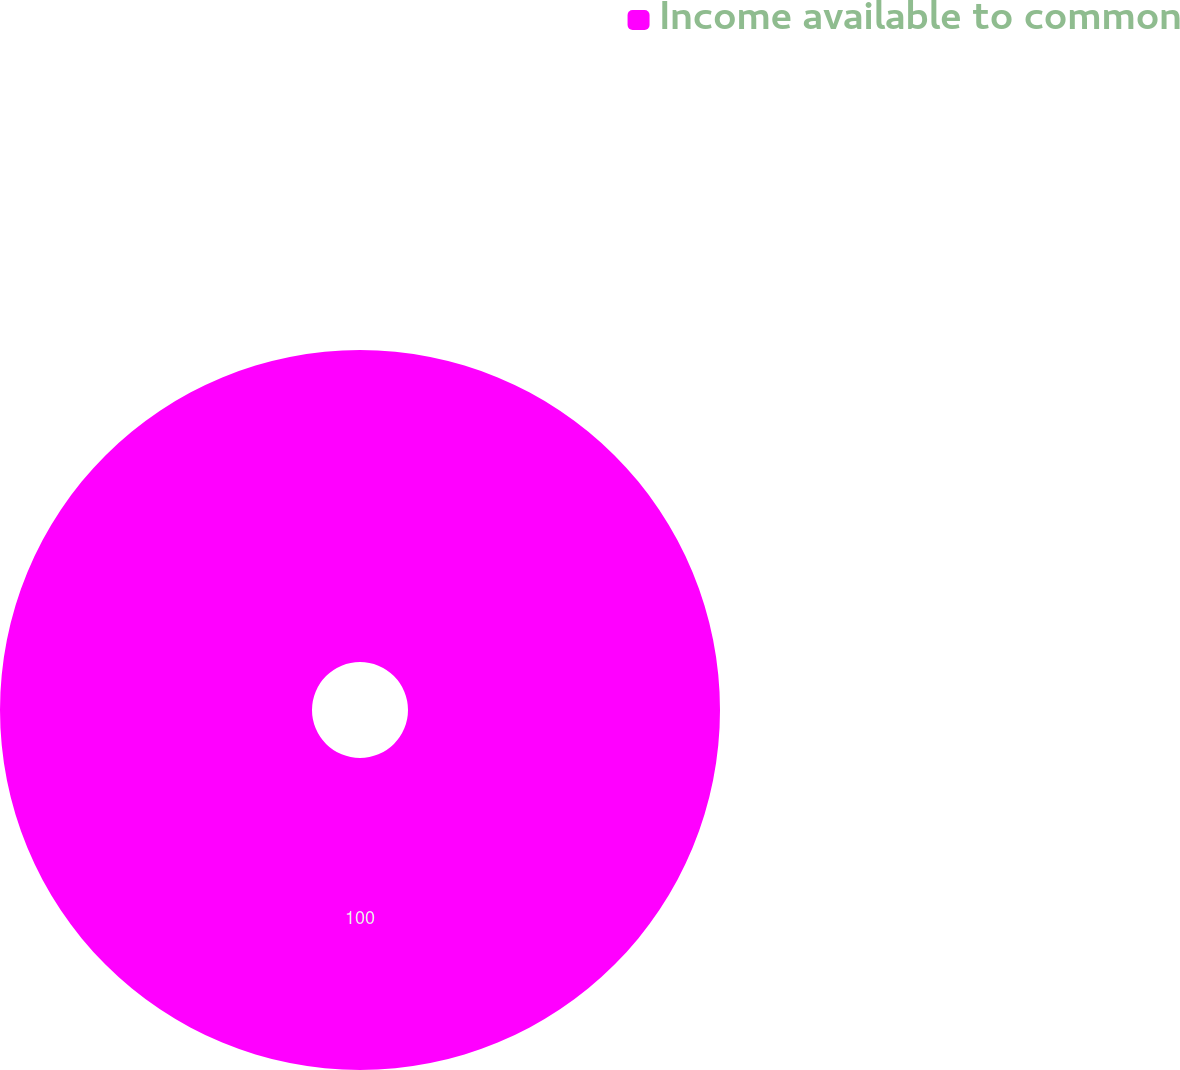Convert chart. <chart><loc_0><loc_0><loc_500><loc_500><pie_chart><fcel>Income available to common<nl><fcel>100.0%<nl></chart> 